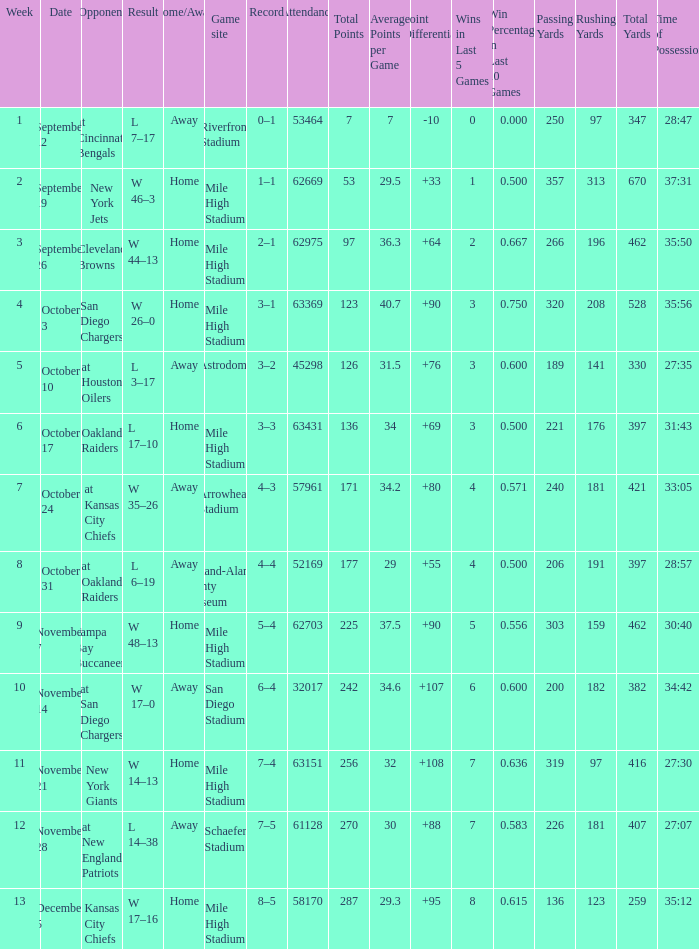What was the date of the week 4 game? October 3. 